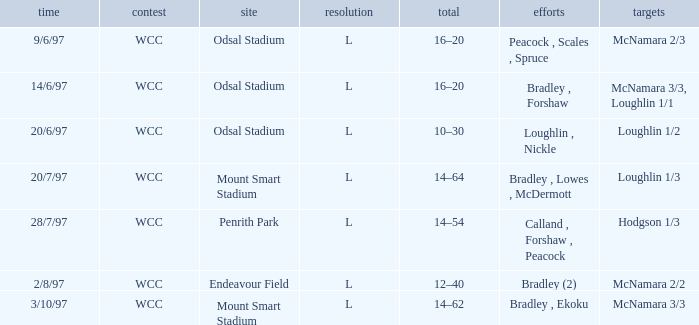What were the goals on 3/10/97? McNamara 3/3. Parse the full table. {'header': ['time', 'contest', 'site', 'resolution', 'total', 'efforts', 'targets'], 'rows': [['9/6/97', 'WCC', 'Odsal Stadium', 'L', '16–20', 'Peacock , Scales , Spruce', 'McNamara 2/3'], ['14/6/97', 'WCC', 'Odsal Stadium', 'L', '16–20', 'Bradley , Forshaw', 'McNamara 3/3, Loughlin 1/1'], ['20/6/97', 'WCC', 'Odsal Stadium', 'L', '10–30', 'Loughlin , Nickle', 'Loughlin 1/2'], ['20/7/97', 'WCC', 'Mount Smart Stadium', 'L', '14–64', 'Bradley , Lowes , McDermott', 'Loughlin 1/3'], ['28/7/97', 'WCC', 'Penrith Park', 'L', '14–54', 'Calland , Forshaw , Peacock', 'Hodgson 1/3'], ['2/8/97', 'WCC', 'Endeavour Field', 'L', '12–40', 'Bradley (2)', 'McNamara 2/2'], ['3/10/97', 'WCC', 'Mount Smart Stadium', 'L', '14–62', 'Bradley , Ekoku', 'McNamara 3/3']]} 